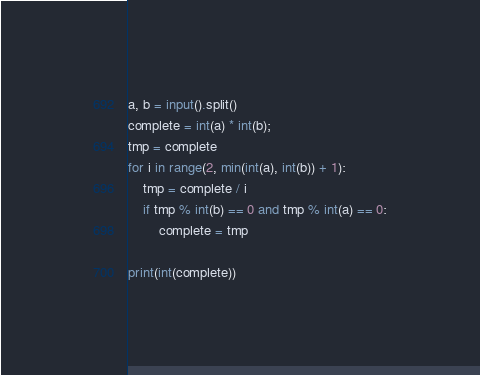<code> <loc_0><loc_0><loc_500><loc_500><_Python_>a, b = input().split()
complete = int(a) * int(b);
tmp = complete
for i in range(2, min(int(a), int(b)) + 1):
    tmp = complete / i
    if tmp % int(b) == 0 and tmp % int(a) == 0:
        complete = tmp

print(int(complete))
</code> 